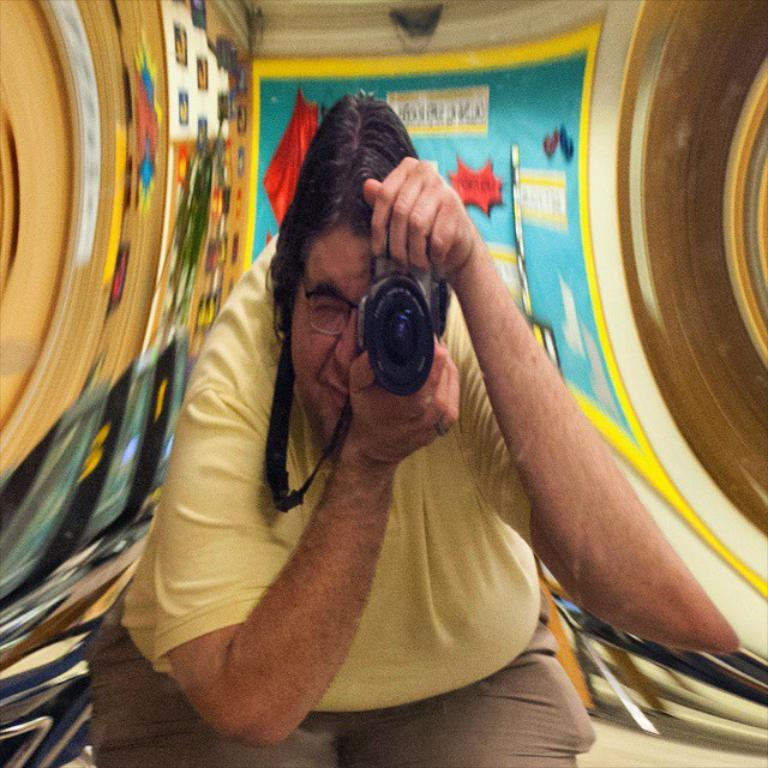What is the main subject of the image? There is a person in the image. What is the person wearing? The person is wearing a yellow t-shirt and spectacles. What is the person holding in the image? The person is holding a camera. What type of key is the person using to unlock the scene in the image? There is no key or scene present in the image; it features a person holding a camera. Is the person wearing a cap in the image? There is no mention of a cap in the provided facts, so we cannot determine if the person is wearing one. 